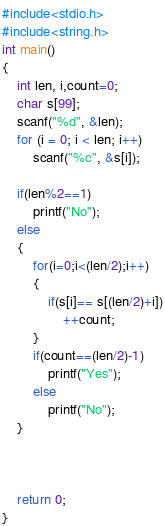Convert code to text. <code><loc_0><loc_0><loc_500><loc_500><_C_>#include<stdio.h>
#include<string.h>
int main()
{
	int len, i,count=0;
	char s[99];
	scanf("%d", &len);
	for (i = 0; i < len; i++)
		scanf("%c", &s[i]);

    if(len%2==1)
        printf("No");
    else
    {
        for(i=0;i<(len/2);i++)
        {
            if(s[i]== s[(len/2)+i])
                ++count;
        }
        if(count==(len/2)-1)
            printf("Yes");
        else
            printf("No");
    }



	return 0;
}
</code> 